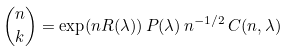Convert formula to latex. <formula><loc_0><loc_0><loc_500><loc_500>\binom { n } { k } = \exp ( n R ( \lambda ) ) \, P ( \lambda ) \, n ^ { - 1 / 2 } \, C ( n , \lambda )</formula> 